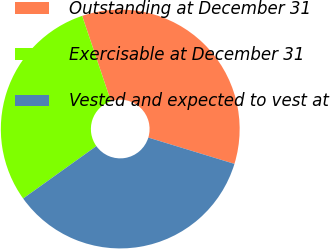<chart> <loc_0><loc_0><loc_500><loc_500><pie_chart><fcel>Outstanding at December 31<fcel>Exercisable at December 31<fcel>Vested and expected to vest at<nl><fcel>34.88%<fcel>29.72%<fcel>35.4%<nl></chart> 